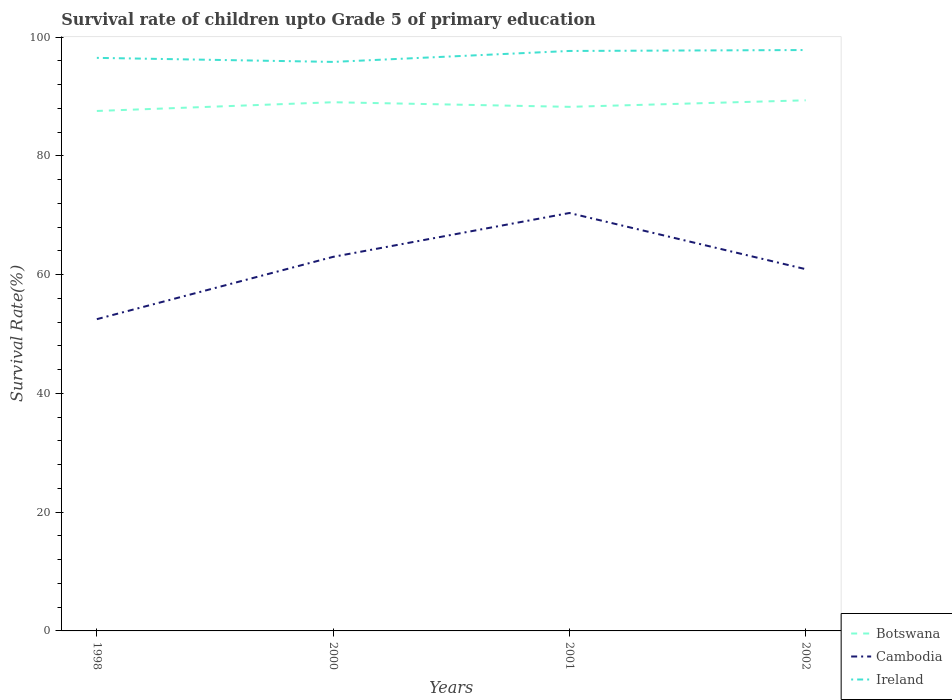How many different coloured lines are there?
Provide a succinct answer. 3. Is the number of lines equal to the number of legend labels?
Keep it short and to the point. Yes. Across all years, what is the maximum survival rate of children in Ireland?
Provide a succinct answer. 95.82. What is the total survival rate of children in Cambodia in the graph?
Your response must be concise. -10.49. What is the difference between the highest and the second highest survival rate of children in Ireland?
Your answer should be compact. 2. What is the difference between the highest and the lowest survival rate of children in Botswana?
Offer a very short reply. 2. How many lines are there?
Make the answer very short. 3. Are the values on the major ticks of Y-axis written in scientific E-notation?
Your answer should be very brief. No. Does the graph contain any zero values?
Provide a succinct answer. No. Does the graph contain grids?
Offer a very short reply. No. Where does the legend appear in the graph?
Provide a succinct answer. Bottom right. What is the title of the graph?
Provide a short and direct response. Survival rate of children upto Grade 5 of primary education. Does "Nicaragua" appear as one of the legend labels in the graph?
Your answer should be compact. No. What is the label or title of the X-axis?
Your answer should be very brief. Years. What is the label or title of the Y-axis?
Offer a very short reply. Survival Rate(%). What is the Survival Rate(%) in Botswana in 1998?
Make the answer very short. 87.56. What is the Survival Rate(%) of Cambodia in 1998?
Keep it short and to the point. 52.5. What is the Survival Rate(%) in Ireland in 1998?
Your answer should be compact. 96.5. What is the Survival Rate(%) in Botswana in 2000?
Keep it short and to the point. 89.03. What is the Survival Rate(%) in Cambodia in 2000?
Make the answer very short. 62.99. What is the Survival Rate(%) of Ireland in 2000?
Offer a terse response. 95.82. What is the Survival Rate(%) in Botswana in 2001?
Your answer should be compact. 88.25. What is the Survival Rate(%) in Cambodia in 2001?
Give a very brief answer. 70.37. What is the Survival Rate(%) of Ireland in 2001?
Keep it short and to the point. 97.66. What is the Survival Rate(%) in Botswana in 2002?
Provide a short and direct response. 89.35. What is the Survival Rate(%) in Cambodia in 2002?
Your answer should be compact. 60.92. What is the Survival Rate(%) in Ireland in 2002?
Make the answer very short. 97.82. Across all years, what is the maximum Survival Rate(%) of Botswana?
Make the answer very short. 89.35. Across all years, what is the maximum Survival Rate(%) of Cambodia?
Give a very brief answer. 70.37. Across all years, what is the maximum Survival Rate(%) in Ireland?
Provide a short and direct response. 97.82. Across all years, what is the minimum Survival Rate(%) of Botswana?
Give a very brief answer. 87.56. Across all years, what is the minimum Survival Rate(%) of Cambodia?
Offer a very short reply. 52.5. Across all years, what is the minimum Survival Rate(%) of Ireland?
Offer a terse response. 95.82. What is the total Survival Rate(%) in Botswana in the graph?
Your answer should be very brief. 354.19. What is the total Survival Rate(%) of Cambodia in the graph?
Your answer should be very brief. 246.78. What is the total Survival Rate(%) in Ireland in the graph?
Keep it short and to the point. 387.79. What is the difference between the Survival Rate(%) of Botswana in 1998 and that in 2000?
Provide a succinct answer. -1.47. What is the difference between the Survival Rate(%) in Cambodia in 1998 and that in 2000?
Provide a succinct answer. -10.49. What is the difference between the Survival Rate(%) in Ireland in 1998 and that in 2000?
Offer a terse response. 0.68. What is the difference between the Survival Rate(%) of Botswana in 1998 and that in 2001?
Make the answer very short. -0.7. What is the difference between the Survival Rate(%) of Cambodia in 1998 and that in 2001?
Give a very brief answer. -17.88. What is the difference between the Survival Rate(%) in Ireland in 1998 and that in 2001?
Provide a short and direct response. -1.16. What is the difference between the Survival Rate(%) in Botswana in 1998 and that in 2002?
Offer a terse response. -1.8. What is the difference between the Survival Rate(%) in Cambodia in 1998 and that in 2002?
Provide a short and direct response. -8.42. What is the difference between the Survival Rate(%) of Ireland in 1998 and that in 2002?
Offer a very short reply. -1.32. What is the difference between the Survival Rate(%) of Botswana in 2000 and that in 2001?
Make the answer very short. 0.78. What is the difference between the Survival Rate(%) of Cambodia in 2000 and that in 2001?
Your answer should be very brief. -7.38. What is the difference between the Survival Rate(%) in Ireland in 2000 and that in 2001?
Provide a short and direct response. -1.84. What is the difference between the Survival Rate(%) of Botswana in 2000 and that in 2002?
Provide a succinct answer. -0.32. What is the difference between the Survival Rate(%) of Cambodia in 2000 and that in 2002?
Ensure brevity in your answer.  2.08. What is the difference between the Survival Rate(%) in Ireland in 2000 and that in 2002?
Offer a very short reply. -2. What is the difference between the Survival Rate(%) of Botswana in 2001 and that in 2002?
Give a very brief answer. -1.1. What is the difference between the Survival Rate(%) in Cambodia in 2001 and that in 2002?
Offer a terse response. 9.46. What is the difference between the Survival Rate(%) in Ireland in 2001 and that in 2002?
Offer a terse response. -0.16. What is the difference between the Survival Rate(%) in Botswana in 1998 and the Survival Rate(%) in Cambodia in 2000?
Your answer should be very brief. 24.56. What is the difference between the Survival Rate(%) in Botswana in 1998 and the Survival Rate(%) in Ireland in 2000?
Offer a very short reply. -8.26. What is the difference between the Survival Rate(%) of Cambodia in 1998 and the Survival Rate(%) of Ireland in 2000?
Keep it short and to the point. -43.32. What is the difference between the Survival Rate(%) in Botswana in 1998 and the Survival Rate(%) in Cambodia in 2001?
Give a very brief answer. 17.18. What is the difference between the Survival Rate(%) of Botswana in 1998 and the Survival Rate(%) of Ireland in 2001?
Provide a short and direct response. -10.11. What is the difference between the Survival Rate(%) in Cambodia in 1998 and the Survival Rate(%) in Ireland in 2001?
Give a very brief answer. -45.16. What is the difference between the Survival Rate(%) of Botswana in 1998 and the Survival Rate(%) of Cambodia in 2002?
Make the answer very short. 26.64. What is the difference between the Survival Rate(%) in Botswana in 1998 and the Survival Rate(%) in Ireland in 2002?
Provide a short and direct response. -10.26. What is the difference between the Survival Rate(%) in Cambodia in 1998 and the Survival Rate(%) in Ireland in 2002?
Offer a terse response. -45.32. What is the difference between the Survival Rate(%) of Botswana in 2000 and the Survival Rate(%) of Cambodia in 2001?
Provide a short and direct response. 18.65. What is the difference between the Survival Rate(%) of Botswana in 2000 and the Survival Rate(%) of Ireland in 2001?
Your answer should be very brief. -8.63. What is the difference between the Survival Rate(%) in Cambodia in 2000 and the Survival Rate(%) in Ireland in 2001?
Offer a very short reply. -34.67. What is the difference between the Survival Rate(%) of Botswana in 2000 and the Survival Rate(%) of Cambodia in 2002?
Offer a very short reply. 28.11. What is the difference between the Survival Rate(%) in Botswana in 2000 and the Survival Rate(%) in Ireland in 2002?
Offer a terse response. -8.79. What is the difference between the Survival Rate(%) of Cambodia in 2000 and the Survival Rate(%) of Ireland in 2002?
Provide a succinct answer. -34.83. What is the difference between the Survival Rate(%) in Botswana in 2001 and the Survival Rate(%) in Cambodia in 2002?
Make the answer very short. 27.34. What is the difference between the Survival Rate(%) in Botswana in 2001 and the Survival Rate(%) in Ireland in 2002?
Give a very brief answer. -9.57. What is the difference between the Survival Rate(%) of Cambodia in 2001 and the Survival Rate(%) of Ireland in 2002?
Your answer should be compact. -27.44. What is the average Survival Rate(%) of Botswana per year?
Make the answer very short. 88.55. What is the average Survival Rate(%) of Cambodia per year?
Your response must be concise. 61.69. What is the average Survival Rate(%) of Ireland per year?
Provide a short and direct response. 96.95. In the year 1998, what is the difference between the Survival Rate(%) of Botswana and Survival Rate(%) of Cambodia?
Ensure brevity in your answer.  35.06. In the year 1998, what is the difference between the Survival Rate(%) in Botswana and Survival Rate(%) in Ireland?
Your answer should be compact. -8.94. In the year 1998, what is the difference between the Survival Rate(%) of Cambodia and Survival Rate(%) of Ireland?
Provide a short and direct response. -44. In the year 2000, what is the difference between the Survival Rate(%) of Botswana and Survival Rate(%) of Cambodia?
Provide a succinct answer. 26.04. In the year 2000, what is the difference between the Survival Rate(%) of Botswana and Survival Rate(%) of Ireland?
Provide a succinct answer. -6.79. In the year 2000, what is the difference between the Survival Rate(%) of Cambodia and Survival Rate(%) of Ireland?
Your response must be concise. -32.83. In the year 2001, what is the difference between the Survival Rate(%) in Botswana and Survival Rate(%) in Cambodia?
Your answer should be compact. 17.88. In the year 2001, what is the difference between the Survival Rate(%) in Botswana and Survival Rate(%) in Ireland?
Provide a succinct answer. -9.41. In the year 2001, what is the difference between the Survival Rate(%) in Cambodia and Survival Rate(%) in Ireland?
Your answer should be very brief. -27.29. In the year 2002, what is the difference between the Survival Rate(%) of Botswana and Survival Rate(%) of Cambodia?
Make the answer very short. 28.44. In the year 2002, what is the difference between the Survival Rate(%) in Botswana and Survival Rate(%) in Ireland?
Make the answer very short. -8.47. In the year 2002, what is the difference between the Survival Rate(%) of Cambodia and Survival Rate(%) of Ireland?
Your answer should be very brief. -36.9. What is the ratio of the Survival Rate(%) of Botswana in 1998 to that in 2000?
Your response must be concise. 0.98. What is the ratio of the Survival Rate(%) in Cambodia in 1998 to that in 2000?
Make the answer very short. 0.83. What is the ratio of the Survival Rate(%) of Ireland in 1998 to that in 2000?
Your response must be concise. 1.01. What is the ratio of the Survival Rate(%) in Cambodia in 1998 to that in 2001?
Give a very brief answer. 0.75. What is the ratio of the Survival Rate(%) in Ireland in 1998 to that in 2001?
Your answer should be compact. 0.99. What is the ratio of the Survival Rate(%) of Botswana in 1998 to that in 2002?
Offer a terse response. 0.98. What is the ratio of the Survival Rate(%) in Cambodia in 1998 to that in 2002?
Give a very brief answer. 0.86. What is the ratio of the Survival Rate(%) of Ireland in 1998 to that in 2002?
Your response must be concise. 0.99. What is the ratio of the Survival Rate(%) of Botswana in 2000 to that in 2001?
Offer a very short reply. 1.01. What is the ratio of the Survival Rate(%) in Cambodia in 2000 to that in 2001?
Your response must be concise. 0.9. What is the ratio of the Survival Rate(%) in Ireland in 2000 to that in 2001?
Ensure brevity in your answer.  0.98. What is the ratio of the Survival Rate(%) in Cambodia in 2000 to that in 2002?
Make the answer very short. 1.03. What is the ratio of the Survival Rate(%) of Ireland in 2000 to that in 2002?
Make the answer very short. 0.98. What is the ratio of the Survival Rate(%) in Botswana in 2001 to that in 2002?
Your answer should be very brief. 0.99. What is the ratio of the Survival Rate(%) in Cambodia in 2001 to that in 2002?
Ensure brevity in your answer.  1.16. What is the difference between the highest and the second highest Survival Rate(%) in Botswana?
Give a very brief answer. 0.32. What is the difference between the highest and the second highest Survival Rate(%) in Cambodia?
Offer a terse response. 7.38. What is the difference between the highest and the second highest Survival Rate(%) in Ireland?
Provide a succinct answer. 0.16. What is the difference between the highest and the lowest Survival Rate(%) in Botswana?
Provide a short and direct response. 1.8. What is the difference between the highest and the lowest Survival Rate(%) in Cambodia?
Keep it short and to the point. 17.88. What is the difference between the highest and the lowest Survival Rate(%) in Ireland?
Ensure brevity in your answer.  2. 